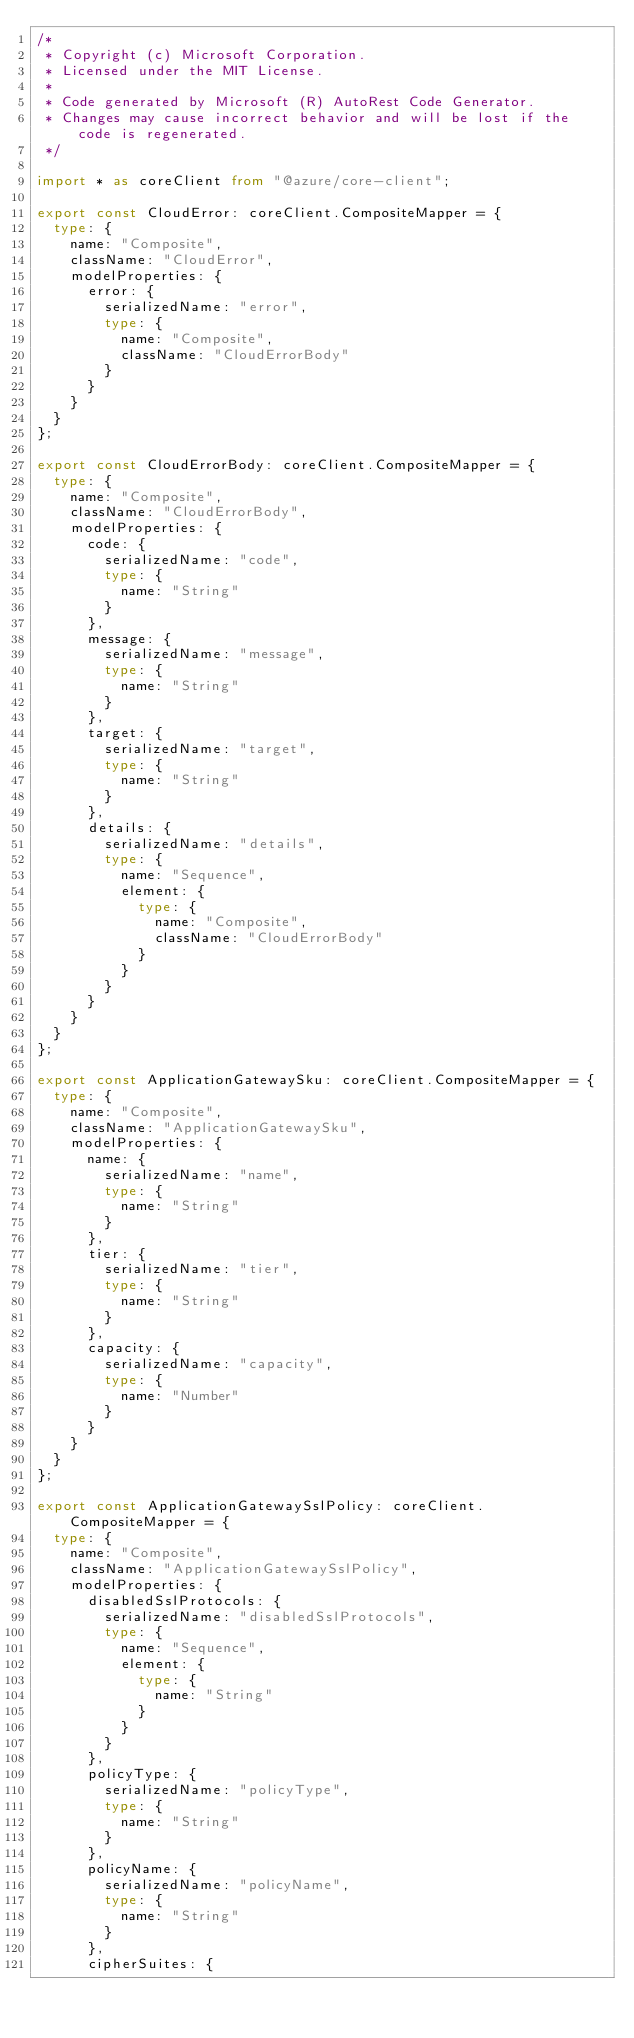Convert code to text. <code><loc_0><loc_0><loc_500><loc_500><_TypeScript_>/*
 * Copyright (c) Microsoft Corporation.
 * Licensed under the MIT License.
 *
 * Code generated by Microsoft (R) AutoRest Code Generator.
 * Changes may cause incorrect behavior and will be lost if the code is regenerated.
 */

import * as coreClient from "@azure/core-client";

export const CloudError: coreClient.CompositeMapper = {
  type: {
    name: "Composite",
    className: "CloudError",
    modelProperties: {
      error: {
        serializedName: "error",
        type: {
          name: "Composite",
          className: "CloudErrorBody"
        }
      }
    }
  }
};

export const CloudErrorBody: coreClient.CompositeMapper = {
  type: {
    name: "Composite",
    className: "CloudErrorBody",
    modelProperties: {
      code: {
        serializedName: "code",
        type: {
          name: "String"
        }
      },
      message: {
        serializedName: "message",
        type: {
          name: "String"
        }
      },
      target: {
        serializedName: "target",
        type: {
          name: "String"
        }
      },
      details: {
        serializedName: "details",
        type: {
          name: "Sequence",
          element: {
            type: {
              name: "Composite",
              className: "CloudErrorBody"
            }
          }
        }
      }
    }
  }
};

export const ApplicationGatewaySku: coreClient.CompositeMapper = {
  type: {
    name: "Composite",
    className: "ApplicationGatewaySku",
    modelProperties: {
      name: {
        serializedName: "name",
        type: {
          name: "String"
        }
      },
      tier: {
        serializedName: "tier",
        type: {
          name: "String"
        }
      },
      capacity: {
        serializedName: "capacity",
        type: {
          name: "Number"
        }
      }
    }
  }
};

export const ApplicationGatewaySslPolicy: coreClient.CompositeMapper = {
  type: {
    name: "Composite",
    className: "ApplicationGatewaySslPolicy",
    modelProperties: {
      disabledSslProtocols: {
        serializedName: "disabledSslProtocols",
        type: {
          name: "Sequence",
          element: {
            type: {
              name: "String"
            }
          }
        }
      },
      policyType: {
        serializedName: "policyType",
        type: {
          name: "String"
        }
      },
      policyName: {
        serializedName: "policyName",
        type: {
          name: "String"
        }
      },
      cipherSuites: {</code> 